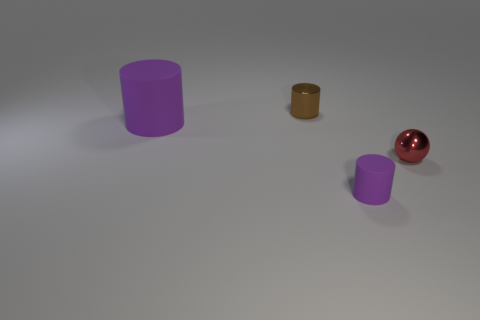There is a small red shiny ball; are there any tiny red metal spheres to the right of it?
Offer a terse response. No. Do the red thing and the brown metal cylinder have the same size?
Ensure brevity in your answer.  Yes. There is another purple object that is the same shape as the tiny rubber thing; what size is it?
Offer a very short reply. Large. The object that is in front of the tiny metal object that is in front of the brown object is made of what material?
Your response must be concise. Rubber. Is the large rubber thing the same shape as the small purple object?
Your response must be concise. Yes. How many tiny things are both left of the red object and right of the small brown cylinder?
Keep it short and to the point. 1. Are there an equal number of red objects behind the red object and brown cylinders that are in front of the brown metal cylinder?
Provide a succinct answer. Yes. Is the size of the cylinder that is in front of the small sphere the same as the shiny object that is behind the red shiny object?
Provide a short and direct response. Yes. What is the material of the cylinder that is both in front of the metallic cylinder and right of the big thing?
Make the answer very short. Rubber. Is the number of red shiny objects less than the number of green rubber cubes?
Provide a succinct answer. No. 